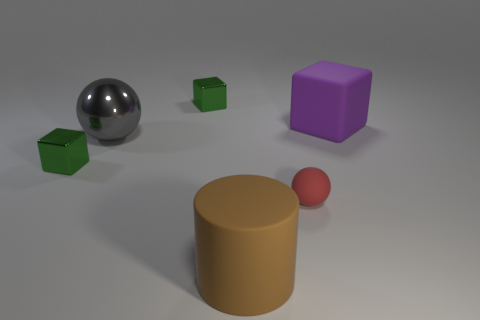How many objects are there in total, and can you describe their shapes? There are five objects in total. Starting from the left, there's a shiny silver sphere, three small green cubes, and a purple cube. In the center, we have a large tan cylinder, and on the far right, a small red sphere. 